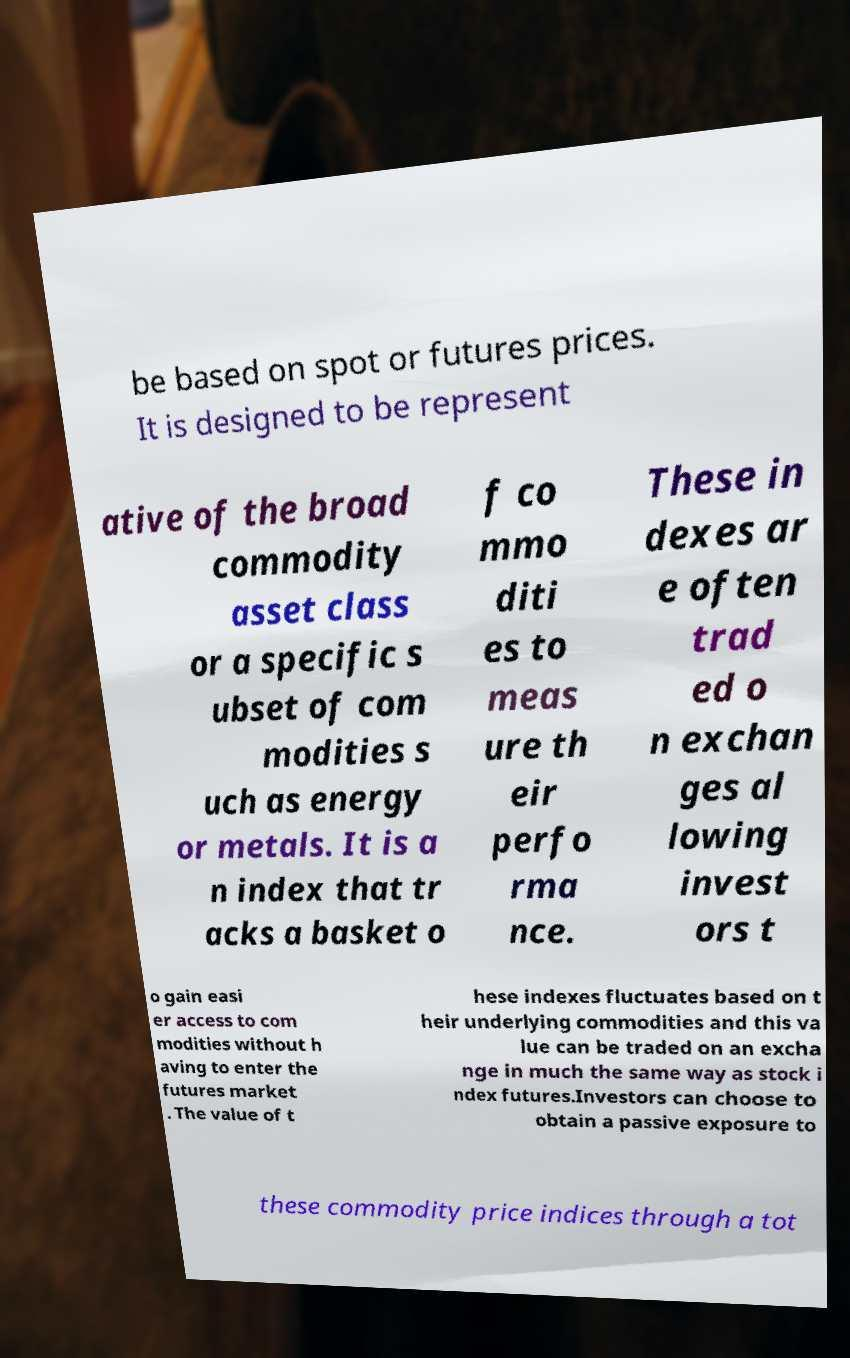Could you assist in decoding the text presented in this image and type it out clearly? be based on spot or futures prices. It is designed to be represent ative of the broad commodity asset class or a specific s ubset of com modities s uch as energy or metals. It is a n index that tr acks a basket o f co mmo diti es to meas ure th eir perfo rma nce. These in dexes ar e often trad ed o n exchan ges al lowing invest ors t o gain easi er access to com modities without h aving to enter the futures market . The value of t hese indexes fluctuates based on t heir underlying commodities and this va lue can be traded on an excha nge in much the same way as stock i ndex futures.Investors can choose to obtain a passive exposure to these commodity price indices through a tot 